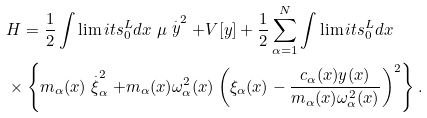<formula> <loc_0><loc_0><loc_500><loc_500>& H = \frac { 1 } { 2 } \int \lim i t s _ { 0 } ^ { L } d x \ \mu \stackrel { . } { y } ^ { 2 } + V [ y ] + \frac { 1 } { 2 } \sum _ { \alpha = 1 } ^ { N } \int \lim i t s _ { 0 } ^ { L } d x \\ & \times \left \{ m _ { \alpha } ( x ) \stackrel { . } { \xi } _ { \alpha } ^ { 2 } + m _ { \alpha } ( x ) \omega _ { \alpha } ^ { 2 } ( x ) \left ( \xi _ { \alpha } ( x ) - \frac { c _ { \alpha } ( x ) y ( x ) } { m _ { \alpha } ( x ) \omega _ { \alpha } ^ { 2 } ( x ) } \right ) ^ { 2 } \right \} .</formula> 